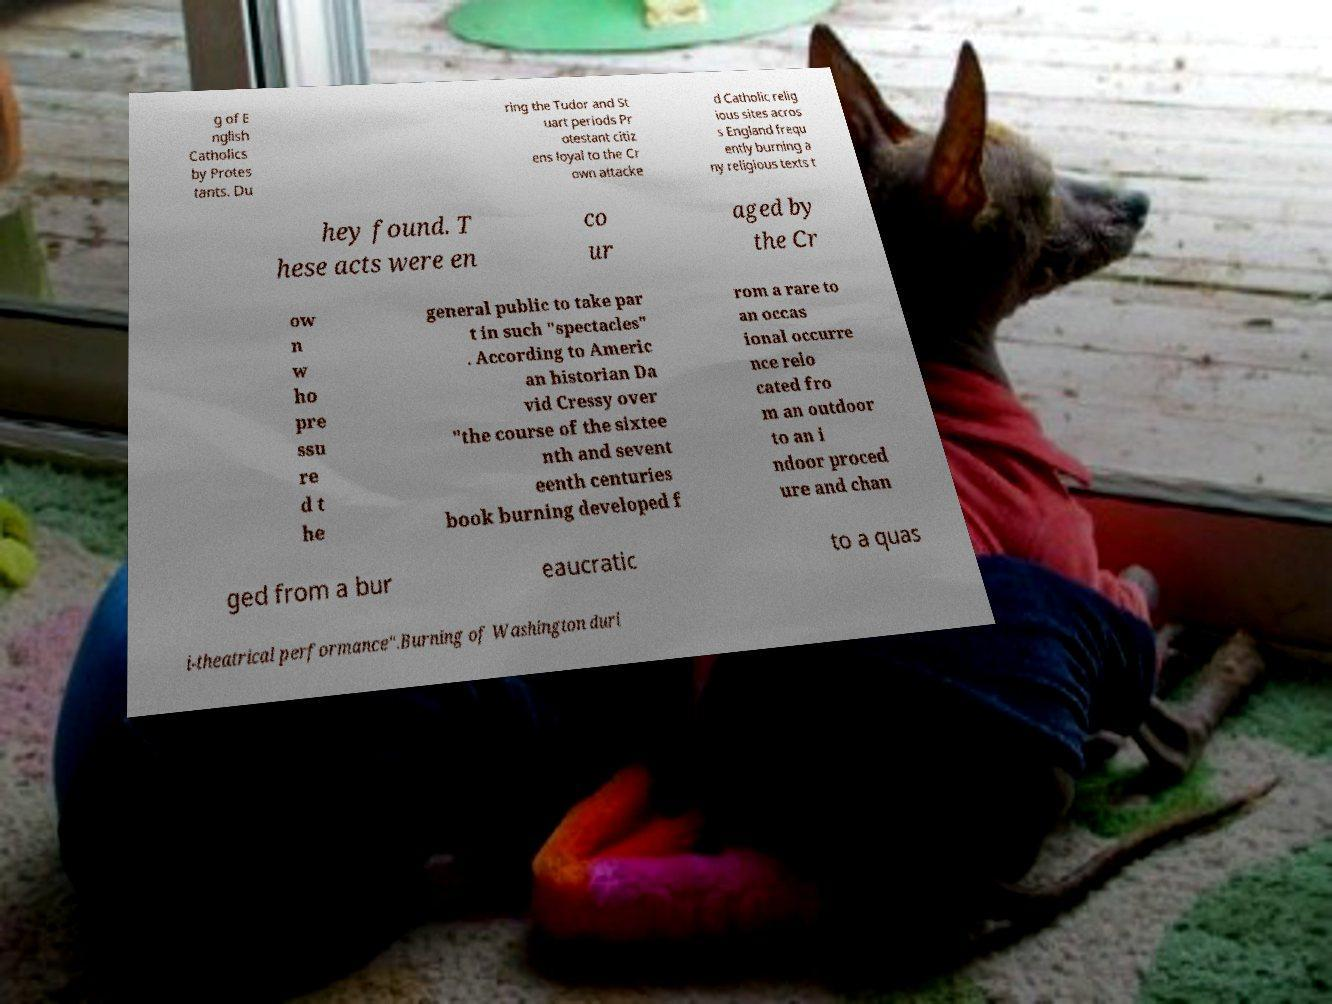Please identify and transcribe the text found in this image. g of E nglish Catholics by Protes tants. Du ring the Tudor and St uart periods Pr otestant citiz ens loyal to the Cr own attacke d Catholic relig ious sites acros s England frequ ently burning a ny religious texts t hey found. T hese acts were en co ur aged by the Cr ow n w ho pre ssu re d t he general public to take par t in such "spectacles" . According to Americ an historian Da vid Cressy over "the course of the sixtee nth and sevent eenth centuries book burning developed f rom a rare to an occas ional occurre nce relo cated fro m an outdoor to an i ndoor proced ure and chan ged from a bur eaucratic to a quas i-theatrical performance".Burning of Washington duri 